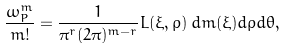Convert formula to latex. <formula><loc_0><loc_0><loc_500><loc_500>\frac { \omega _ { P } ^ { m } } { m ! } = \frac { 1 } { \pi ^ { r } ( 2 \pi ) ^ { m - r } } L ( \xi , \rho ) \, d m ( \xi ) d \rho d \theta ,</formula> 